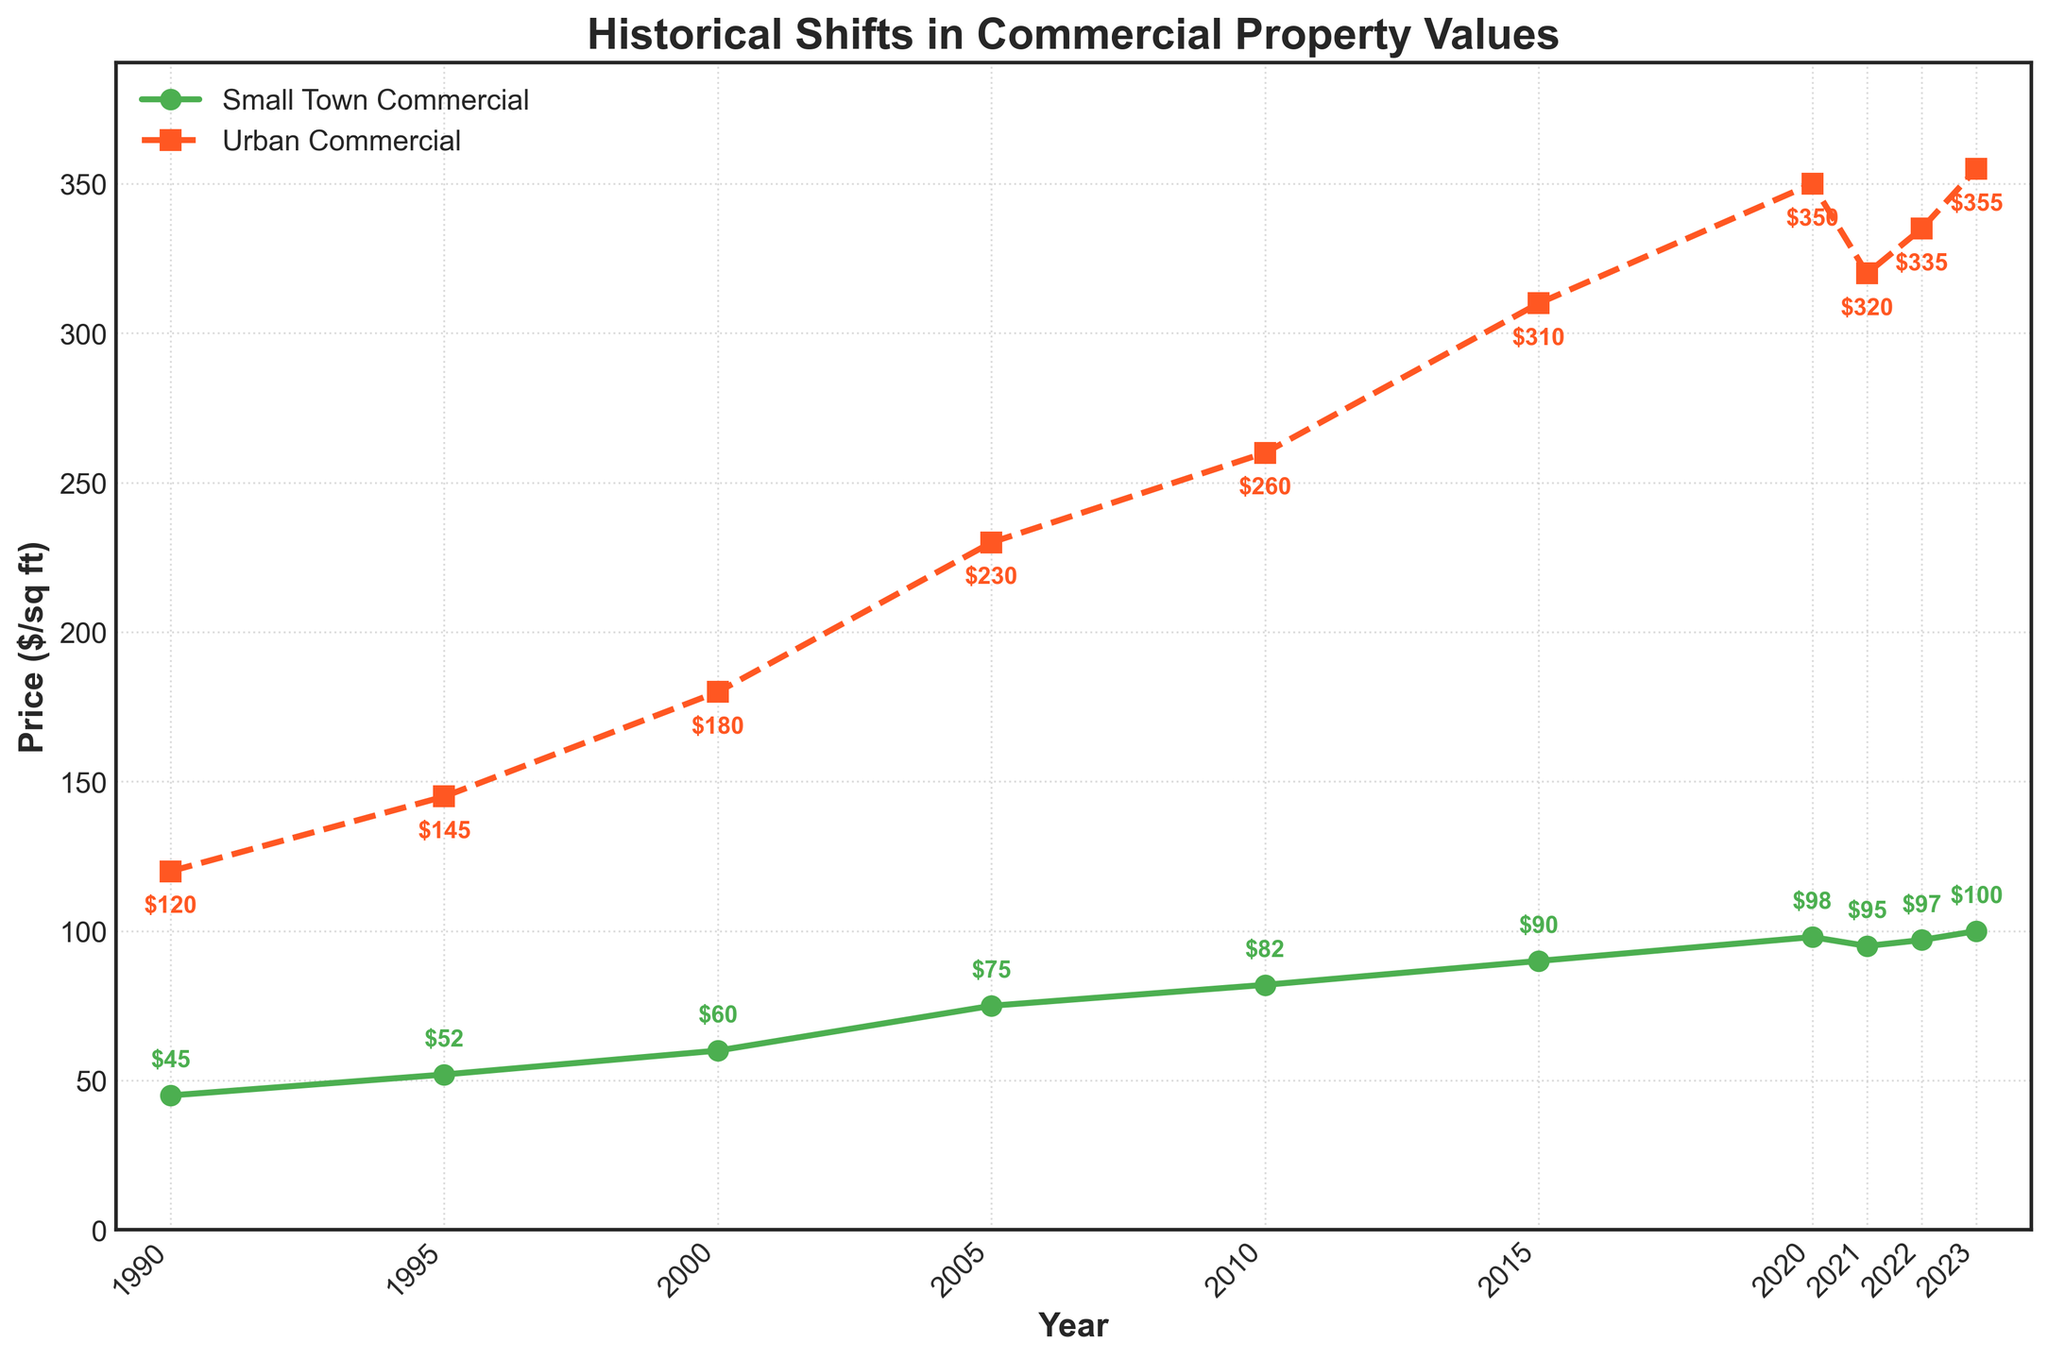what is the property value in small towns in 2020? Refer to the line chart and look for the value of small town commercial property in the year 2020. The marker shows the value as 98 $/sq ft.
Answer: 98 $/sq ft how much did urban commercial property values increase from 1990 to 2023? Determine the difference between the urban commercial property values in 2023 and 1990. The value in 2023 is 355 $/sq ft, and in 1990 it was 120 $/sq ft. Calculate the increase: 355 - 120 = 235 $/sq ft.
Answer: 235 $/sq ft which year shows the highest value for urban commercial property? Look for the highest point on the urban commercial property line. The highest point corresponds to the year 2023, with a value of 355 $/sq ft.
Answer: 2023 what can you say about the trend of small town commercial property values from 1990 to 2023? Examine the line representing small town commercial property values. From 1990 to 2023, there is a general upward trend with some fluctuations, indicating an overall increase in values from 45 $/sq ft to 100 $/sq ft.
Answer: Generally increasing how did the urban commercial property trend change between 2020 and 2021? Observe the slope of the urban commercial property line between 2020 and 2021. There is a noticeable drop from 350 $/sq ft in 2020 to 320 $/sq ft in 2021, indicating a decrease.
Answer: Decrease what is the average value of small town commercial properties in the years 2015, 2020, and 2023? Sum the values of small town commercial properties for the years 2015 (90 $/sq ft), 2020 (98 $/sq ft), and 2023 (100 $/sq ft). Then divide by 3: (90 + 98 + 100) / 3 = 96.
Answer: 96 $/sq ft are the property values for small towns and urban areas closer in 1990 or 2023? Compare the differences in values between small towns and urban areas in 1990 and 2023. For 1990, the difference is 120 - 45 = 75 $/sq ft; for 2023, it's 355 - 100 = 255 $/sq ft. Since 75 is less than 255, the values are closer in 1990.
Answer: 1990 which property type had a more significant percentage increase from 1990 to 2023? Calculate the percentage increase for each property type. For small towns: ((100-45)/45)*100 ≈ 122.22%. For urban properties: ((355-120)/120)*100 ≈ 195.83%. The urban properties had a more significant percentage increase.
Answer: Urban properties what is the difference between the highest and lowest values for small town commercial properties? Locate the highest (100 $/sq ft in 2023) and lowest (45 $/sq ft in 1990) values on the small town commercial property line. Calculate the difference: 100 - 45 = 55 $/sq ft.
Answer: 55 $/sq ft 